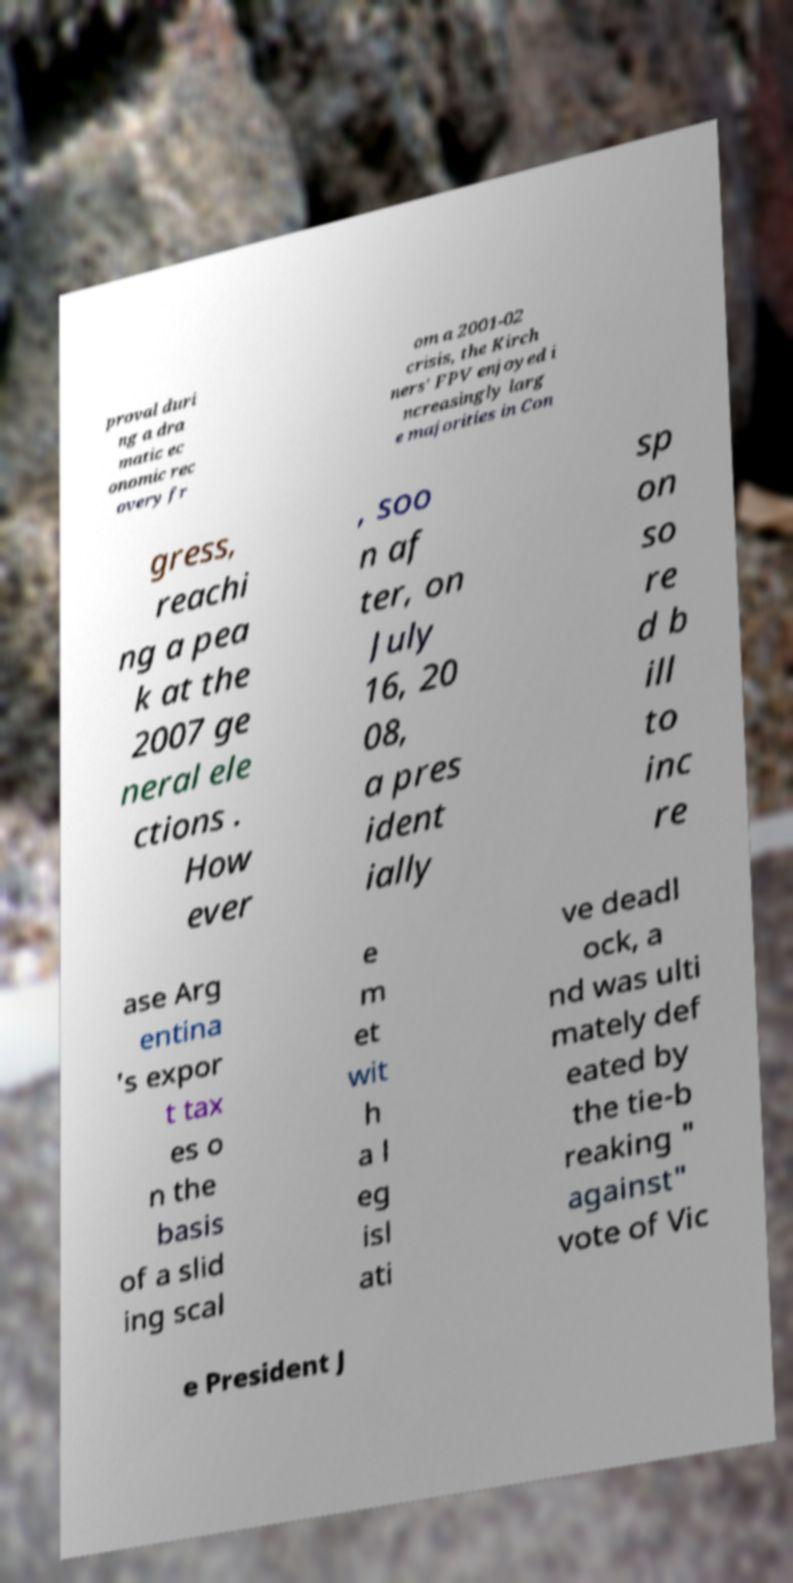Please identify and transcribe the text found in this image. proval duri ng a dra matic ec onomic rec overy fr om a 2001-02 crisis, the Kirch ners' FPV enjoyed i ncreasingly larg e majorities in Con gress, reachi ng a pea k at the 2007 ge neral ele ctions . How ever , soo n af ter, on July 16, 20 08, a pres ident ially sp on so re d b ill to inc re ase Arg entina 's expor t tax es o n the basis of a slid ing scal e m et wit h a l eg isl ati ve deadl ock, a nd was ulti mately def eated by the tie-b reaking " against" vote of Vic e President J 